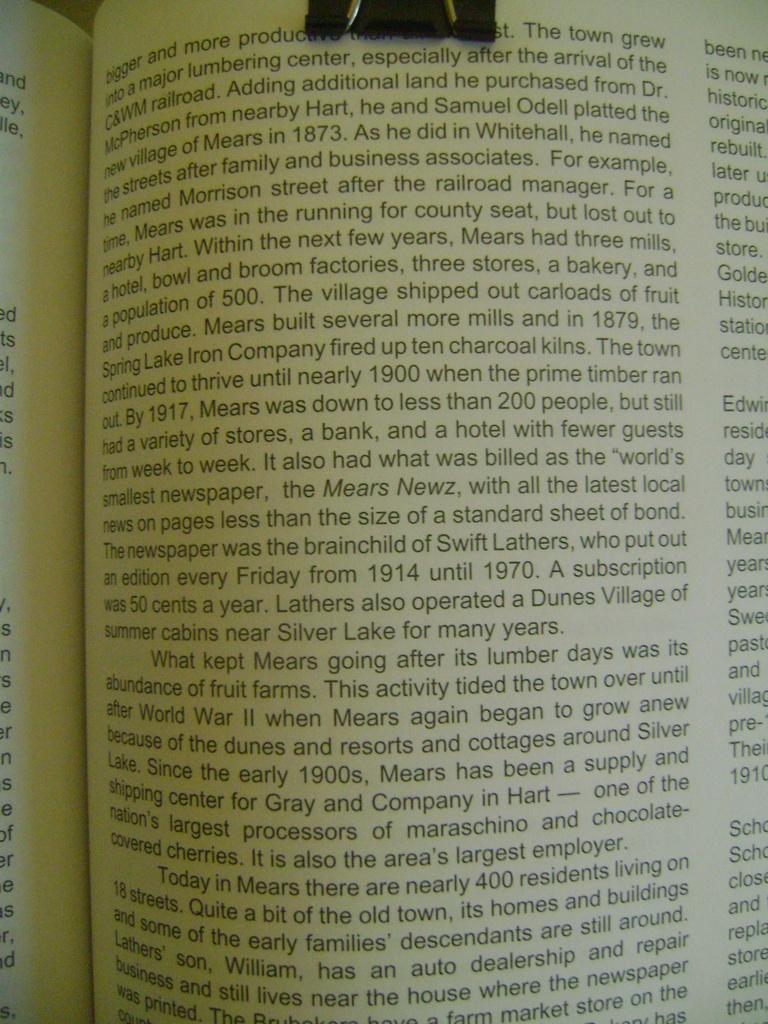Provide a one-sentence caption for the provided image. A book is open to a page with the first word being bigger. 